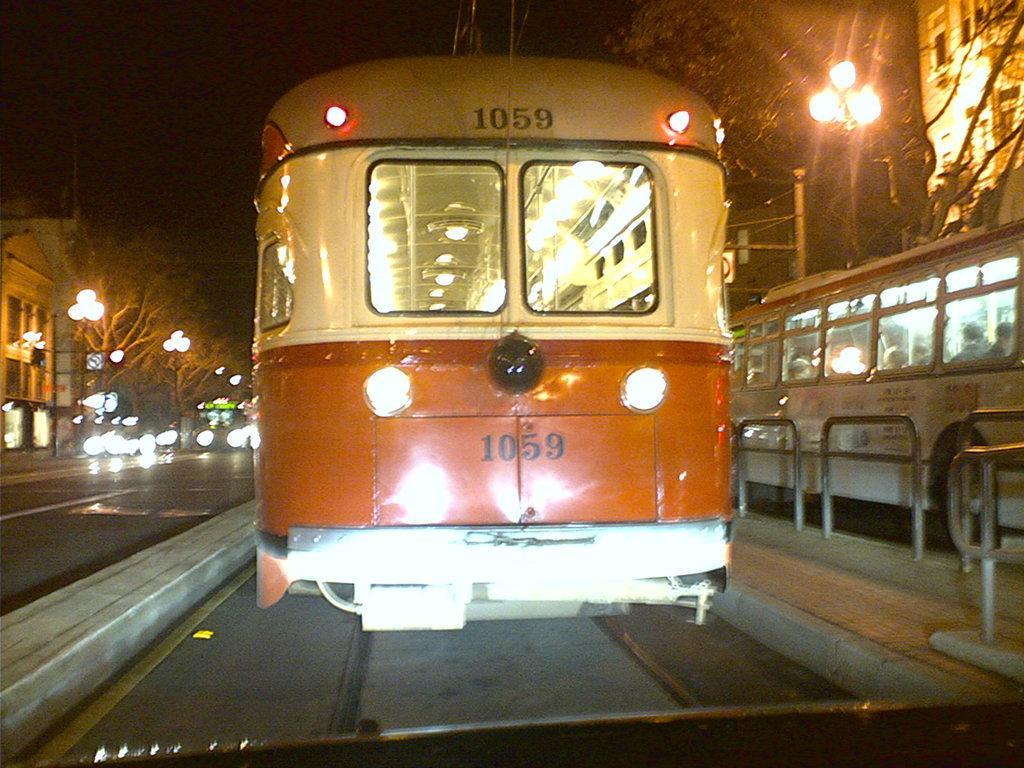Can you describe this image briefly? In this image we can see few vehicles. Beside of vehicles we can see the barrier. Behind the vehicle, there are group of trees, buildings and street poles with lights. 